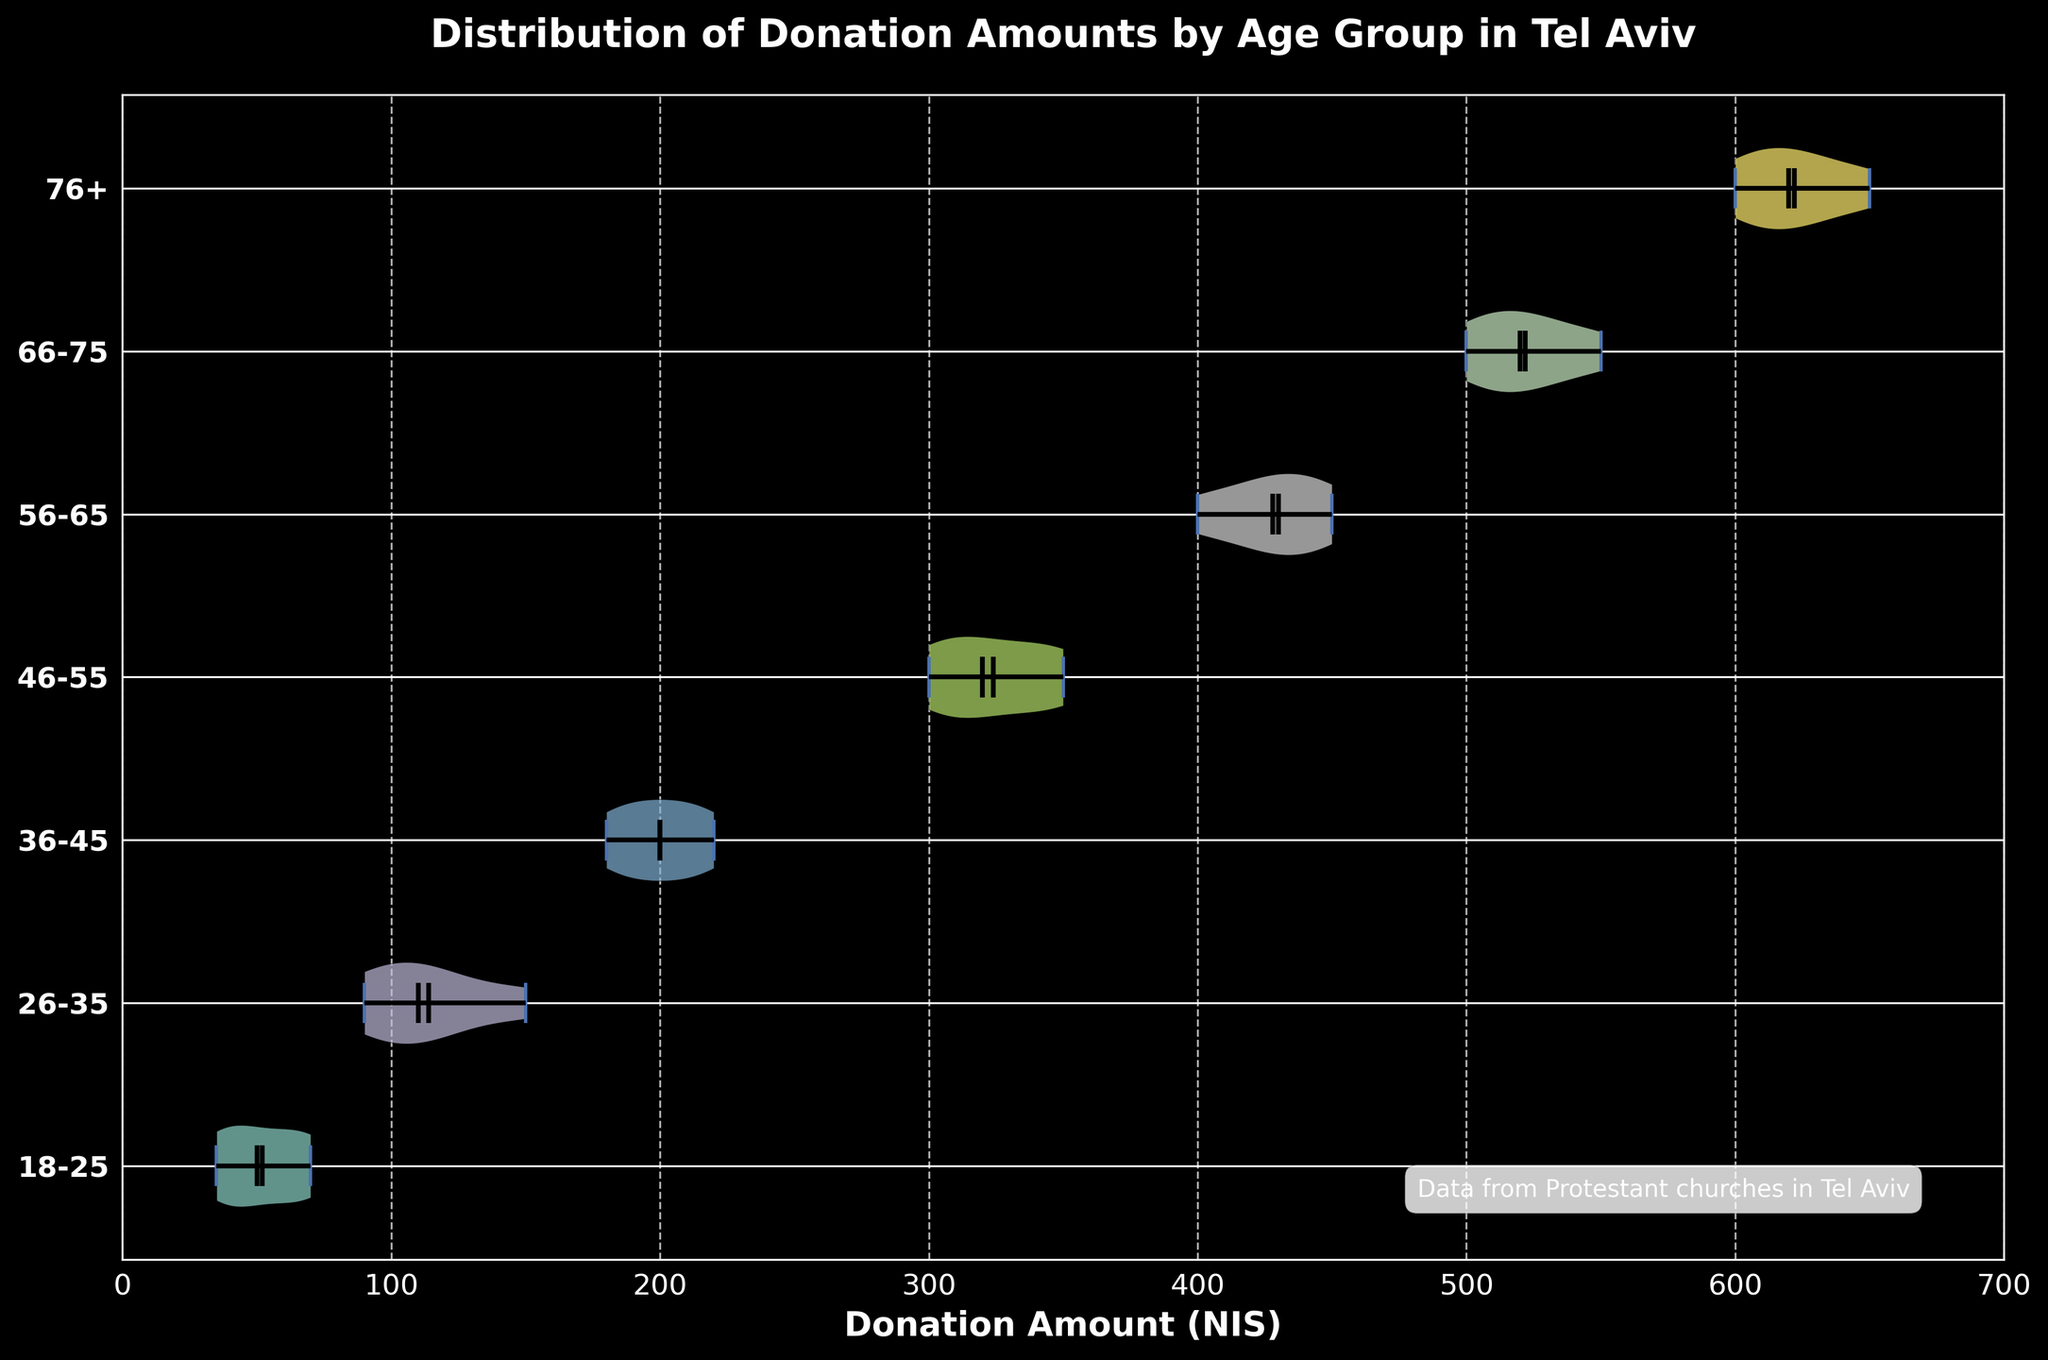What's the title of the plot? The title of the plot is provided at the top of the chart. It typically summarizes the key aspect being visualized.
Answer: Distribution of Donation Amounts by Age Group in Tel Aviv What does the x-axis represent? The x-axis, labeled at the bottom of the chart, indicates the type of data plotted along this axis. It shows the range and units of measurement used.
Answer: Donation Amount (NIS) Which age group has the highest median donation amount? The median is represented by a horizontal line inside each violin. By comparing the medians across groups, the highest median can be identified.
Answer: 76+ Which age group has the lowest mean donation amount? The mean is shown by a dot inside each violin. By comparing the means across groups, the lowest mean can be identified.
Answer: 18-25 What is the range of donation amounts for the 26-35 age group? The range is given by the extremities of the violin plot for a specific age group. This range shows the minimum and maximum values within the distribution.
Answer: 90 to 150 How does the median donation amount of the 46-55 age group compare to the 66-75 age group? The median of each group is a horizontal line. By comparing these lines across the two specified age groups, the relative positions can be assessed.
Answer: The median is higher in the 66-75 age group Which age group's donation amounts appear to be most spread out? The spread of donation amounts is visualized by the width of the violin plot. A wider plot indicates more variability in the donations.
Answer: 76+ What can be inferred from the annotation at the bottom of the plot? The annotation may provide additional context or source information about the data. It's positioned typically in a less prominent area of the plot.
Answer: Data from Protestant churches in Tel Aviv What is the most common donation amount for the 36-45 age group? The mode, or most frequent value, can often be inferred from the bulkiest part of the violin. This indicates where most of the data points are concentrated.
Answer: Around 200 Based on the plot, which age group tends to donate more on average? By looking at the means (dots) across all age groups, it's possible to identify the group with the highest average donation.
Answer: 76+ 